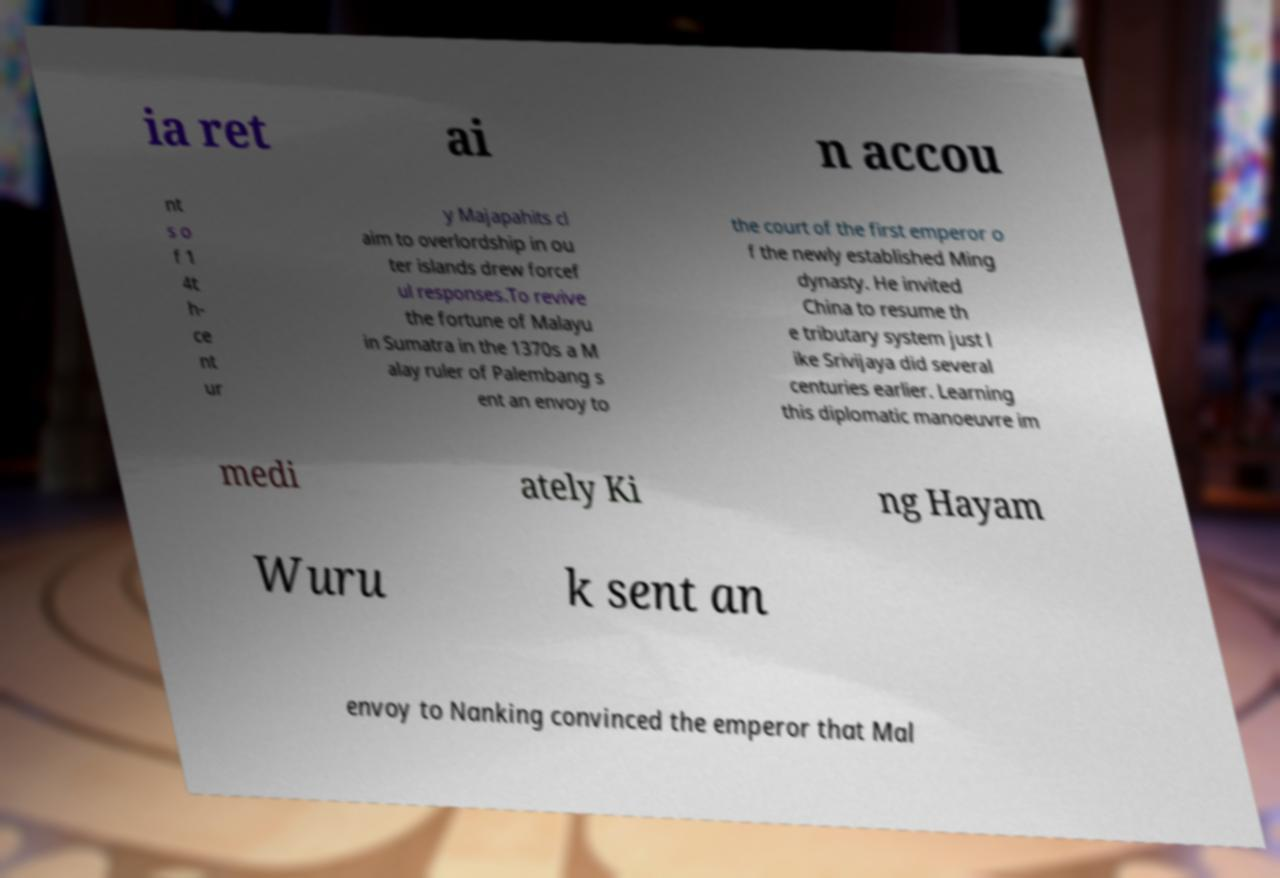I need the written content from this picture converted into text. Can you do that? ia ret ai n accou nt s o f 1 4t h- ce nt ur y Majapahits cl aim to overlordship in ou ter islands drew forcef ul responses.To revive the fortune of Malayu in Sumatra in the 1370s a M alay ruler of Palembang s ent an envoy to the court of the first emperor o f the newly established Ming dynasty. He invited China to resume th e tributary system just l ike Srivijaya did several centuries earlier. Learning this diplomatic manoeuvre im medi ately Ki ng Hayam Wuru k sent an envoy to Nanking convinced the emperor that Mal 